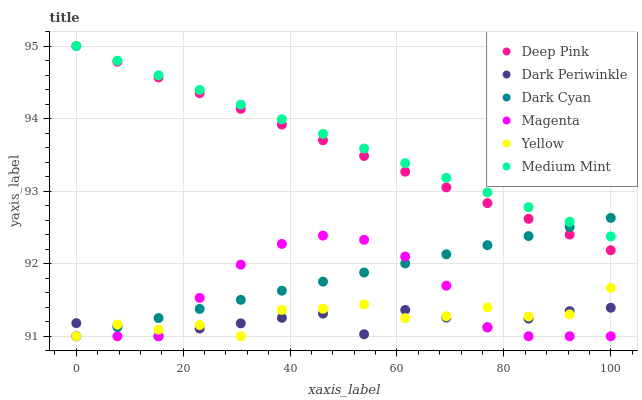Does Dark Periwinkle have the minimum area under the curve?
Answer yes or no. Yes. Does Medium Mint have the maximum area under the curve?
Answer yes or no. Yes. Does Deep Pink have the minimum area under the curve?
Answer yes or no. No. Does Deep Pink have the maximum area under the curve?
Answer yes or no. No. Is Deep Pink the smoothest?
Answer yes or no. Yes. Is Yellow the roughest?
Answer yes or no. Yes. Is Yellow the smoothest?
Answer yes or no. No. Is Deep Pink the roughest?
Answer yes or no. No. Does Yellow have the lowest value?
Answer yes or no. Yes. Does Deep Pink have the lowest value?
Answer yes or no. No. Does Deep Pink have the highest value?
Answer yes or no. Yes. Does Yellow have the highest value?
Answer yes or no. No. Is Magenta less than Deep Pink?
Answer yes or no. Yes. Is Medium Mint greater than Dark Periwinkle?
Answer yes or no. Yes. Does Dark Cyan intersect Yellow?
Answer yes or no. Yes. Is Dark Cyan less than Yellow?
Answer yes or no. No. Is Dark Cyan greater than Yellow?
Answer yes or no. No. Does Magenta intersect Deep Pink?
Answer yes or no. No. 